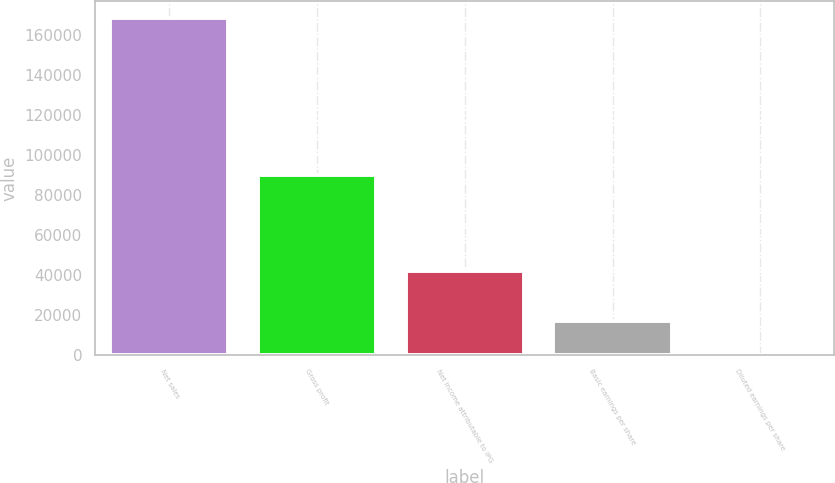Convert chart to OTSL. <chart><loc_0><loc_0><loc_500><loc_500><bar_chart><fcel>Net sales<fcel>Gross profit<fcel>Net income attributable to IPG<fcel>Basic earnings per share<fcel>Diluted earnings per share<nl><fcel>168171<fcel>89922<fcel>41720<fcel>16817.8<fcel>0.8<nl></chart> 